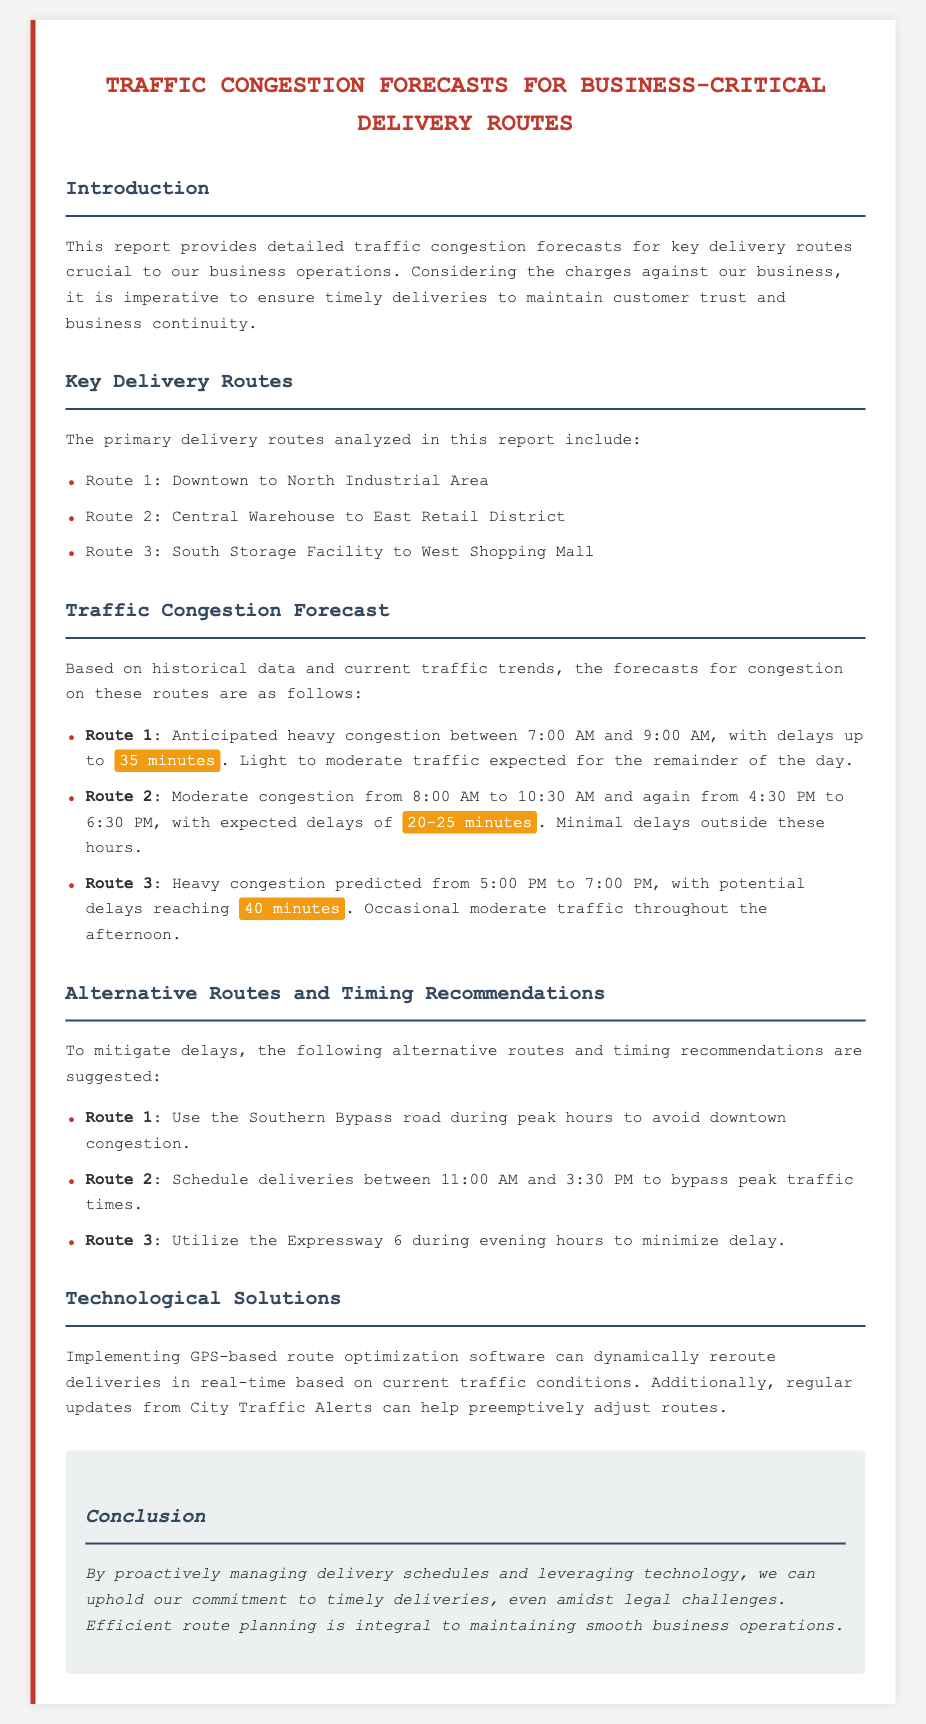What are the three key delivery routes? The document lists three primary delivery routes: Downtown to North Industrial Area, Central Warehouse to East Retail District, and South Storage Facility to West Shopping Mall.
Answer: Downtown to North Industrial Area, Central Warehouse to East Retail District, South Storage Facility to West Shopping Mall What is the expected delay for Route 1 during peak hours? The report indicates that there will be anticipated heavy congestion on Route 1 between 7:00 AM and 9:00 AM, with delays up to 35 minutes.
Answer: 35 minutes When is moderate congestion predicted for Route 2? The report states that moderate congestion for Route 2 is expected from 8:00 AM to 10:30 AM and again from 4:30 PM to 6:30 PM.
Answer: 8:00 AM to 10:30 AM and 4:30 PM to 6:30 PM What alternative route is suggested for Route 1 during peak hours? The document recommends using the Southern Bypass road during peak hours to avoid downtown congestion on Route 1.
Answer: Southern Bypass road How can technology assist in managing delivery routes? The report mentions implementing GPS-based route optimization software can dynamically reroute deliveries in real-time based on current traffic conditions.
Answer: GPS-based route optimization software What is the maximum delay expected for Route 3? The document forecasts heavy congestion on Route 3 from 5:00 PM to 7:00 PM, with potential delays reaching 40 minutes.
Answer: 40 minutes 